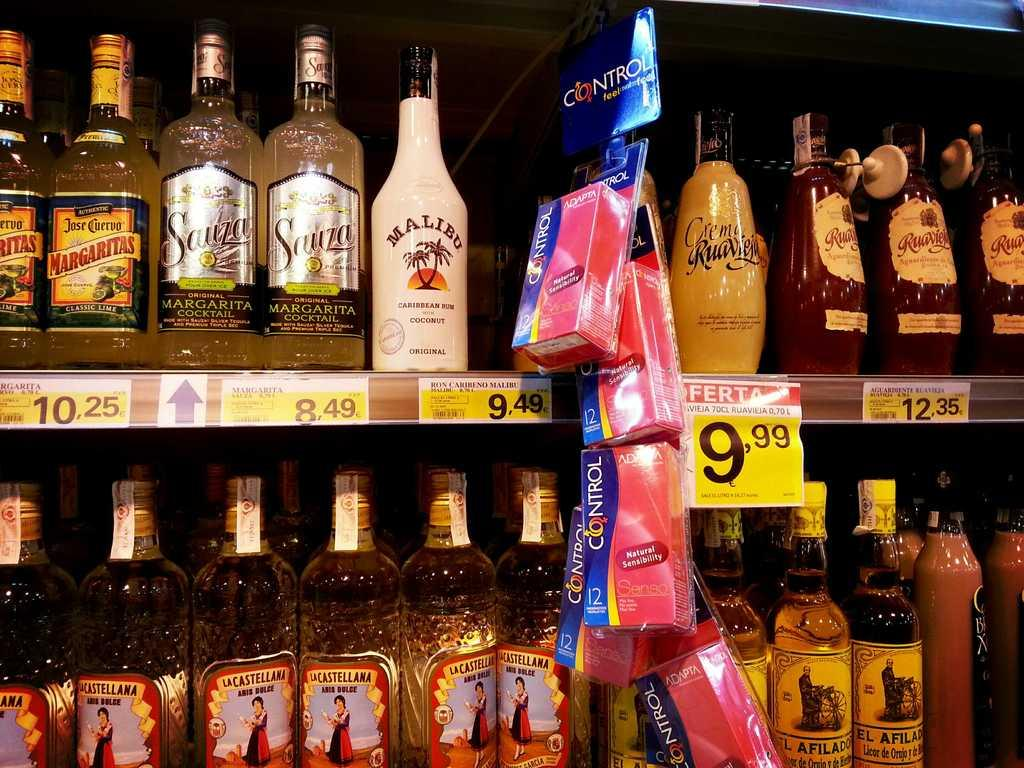<image>
Provide a brief description of the given image. A liquor shelf at a supermarket with bottles including a bottle of Malibu rum. 